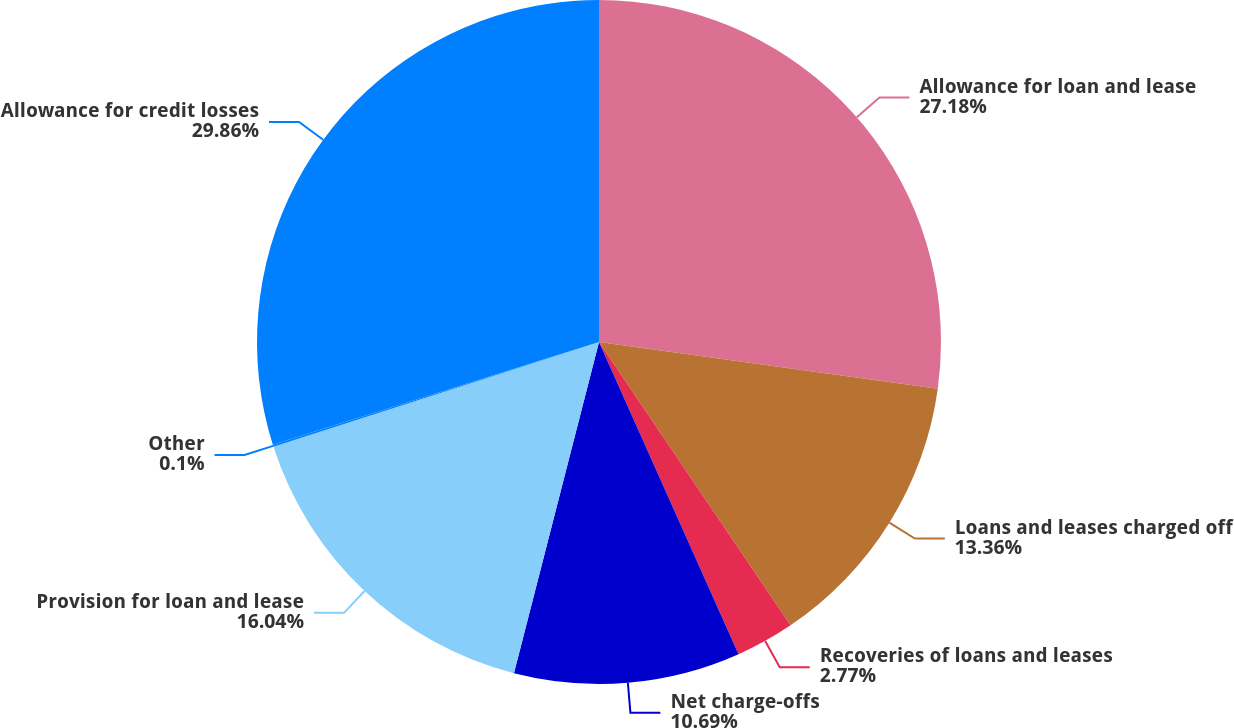Convert chart. <chart><loc_0><loc_0><loc_500><loc_500><pie_chart><fcel>Allowance for loan and lease<fcel>Loans and leases charged off<fcel>Recoveries of loans and leases<fcel>Net charge-offs<fcel>Provision for loan and lease<fcel>Other<fcel>Allowance for credit losses<nl><fcel>27.18%<fcel>13.36%<fcel>2.77%<fcel>10.69%<fcel>16.04%<fcel>0.1%<fcel>29.86%<nl></chart> 